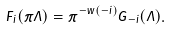Convert formula to latex. <formula><loc_0><loc_0><loc_500><loc_500>F _ { i } ( \pi \Lambda ) = \tilde { \pi } ^ { - w ( - i ) } G _ { - i } ( \Lambda ) .</formula> 